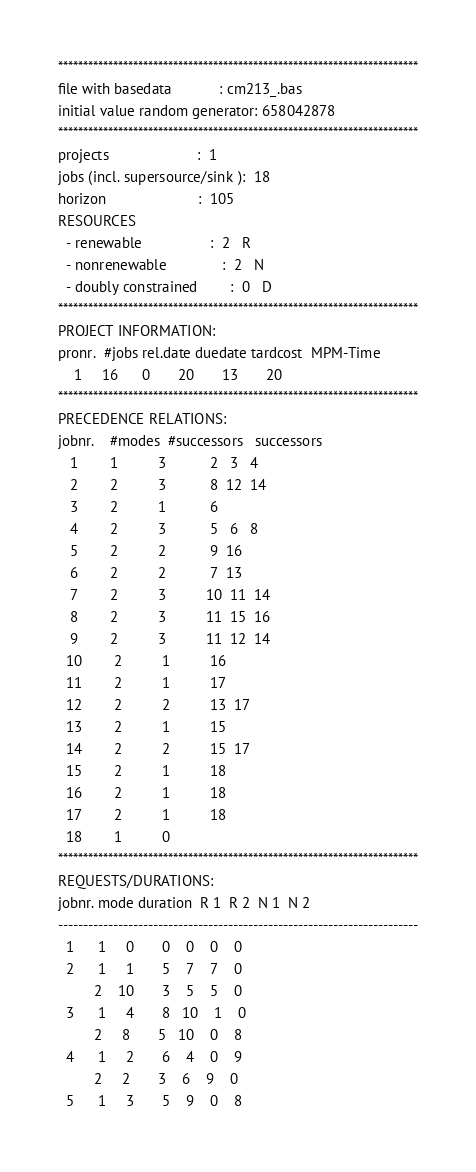<code> <loc_0><loc_0><loc_500><loc_500><_ObjectiveC_>************************************************************************
file with basedata            : cm213_.bas
initial value random generator: 658042878
************************************************************************
projects                      :  1
jobs (incl. supersource/sink ):  18
horizon                       :  105
RESOURCES
  - renewable                 :  2   R
  - nonrenewable              :  2   N
  - doubly constrained        :  0   D
************************************************************************
PROJECT INFORMATION:
pronr.  #jobs rel.date duedate tardcost  MPM-Time
    1     16      0       20       13       20
************************************************************************
PRECEDENCE RELATIONS:
jobnr.    #modes  #successors   successors
   1        1          3           2   3   4
   2        2          3           8  12  14
   3        2          1           6
   4        2          3           5   6   8
   5        2          2           9  16
   6        2          2           7  13
   7        2          3          10  11  14
   8        2          3          11  15  16
   9        2          3          11  12  14
  10        2          1          16
  11        2          1          17
  12        2          2          13  17
  13        2          1          15
  14        2          2          15  17
  15        2          1          18
  16        2          1          18
  17        2          1          18
  18        1          0        
************************************************************************
REQUESTS/DURATIONS:
jobnr. mode duration  R 1  R 2  N 1  N 2
------------------------------------------------------------------------
  1      1     0       0    0    0    0
  2      1     1       5    7    7    0
         2    10       3    5    5    0
  3      1     4       8   10    1    0
         2     8       5   10    0    8
  4      1     2       6    4    0    9
         2     2       3    6    9    0
  5      1     3       5    9    0    8</code> 